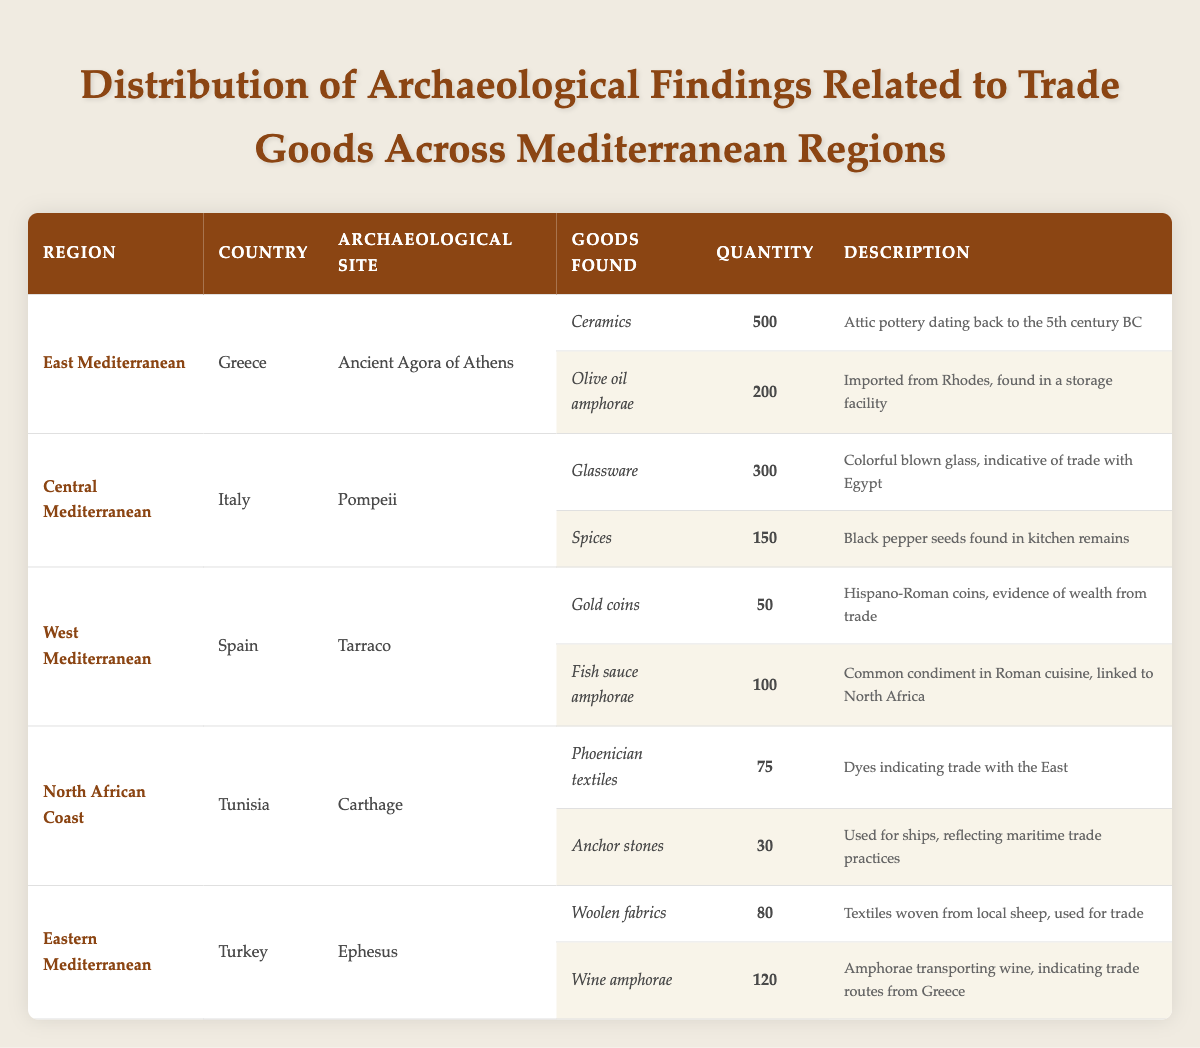What types of goods were found at the Ancient Agora of Athens? The table indicates that two types of goods were discovered at the Ancient Agora of Athens: Ceramics and Olive oil amphorae.
Answer: Ceramics and Olive oil amphorae Which archaeological site in Tunisia had the highest quantity of goods found? At Carthage, there were a total of 105 goods found (75 Phoenician textiles and 30 anchor stones), which is more than the quantities found at other sites listed.
Answer: Carthage What is the total quantity of goods found in Pompeii? The total quantity of goods found in Pompeii can be calculated by adding the quantities of the two goods: Glassware (300) and Spices (150), which equals 450.
Answer: 450 Did Ephesus yield more Woolen fabrics or Wine amphorae? At Ephesus, there are 80 Woolen fabrics and 120 Wine amphorae; hence, more Wine amphorae were found.
Answer: Yes Which region had the least amount of gold coins found and how many? The West Mediterranean region, specifically in Tarraco, had the least amount of gold coins found, totaling 50.
Answer: 50 What is the difference in the quantity of Fish sauce amphorae found in Tarraco and Olive oil amphorae in Athens? The quantity of Fish sauce amphorae found in Tarraco is 100, while Olive oil amphorae in Athens total 200. The difference is 200 - 100 = 100.
Answer: 100 Which region had the most diverse types of goods found based on the table? The East Mediterranean region had two distinct types of goods (Ceramics and Olive oil amphorae), while all other regions also had two goods, making them equally diverse without offering a clear distinction in this dataset.
Answer: Equal diversity across regions 